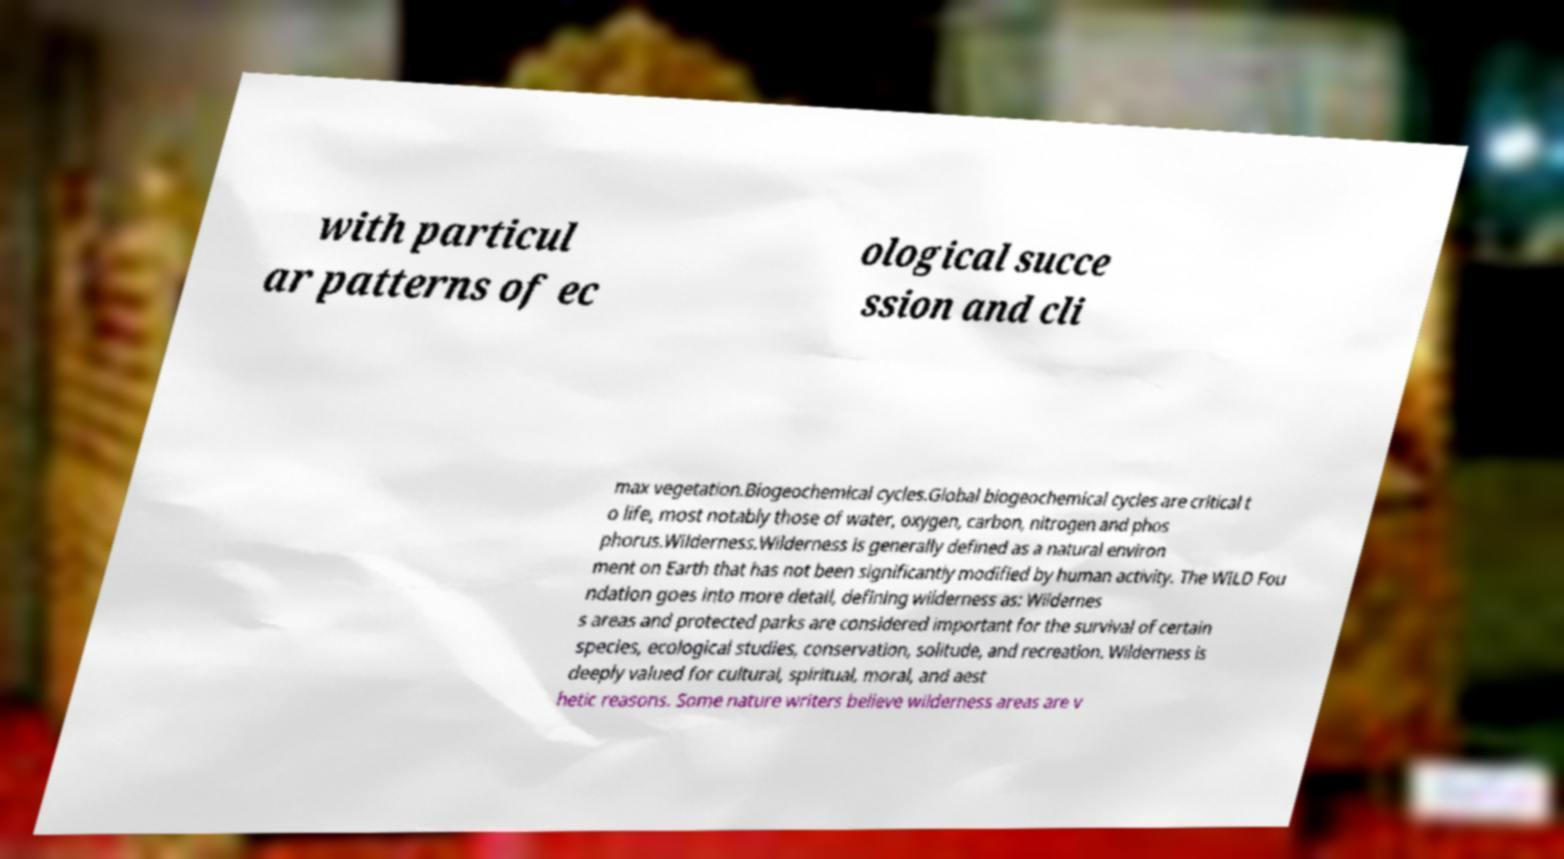Please identify and transcribe the text found in this image. with particul ar patterns of ec ological succe ssion and cli max vegetation.Biogeochemical cycles.Global biogeochemical cycles are critical t o life, most notably those of water, oxygen, carbon, nitrogen and phos phorus.Wilderness.Wilderness is generally defined as a natural environ ment on Earth that has not been significantly modified by human activity. The WILD Fou ndation goes into more detail, defining wilderness as: Wildernes s areas and protected parks are considered important for the survival of certain species, ecological studies, conservation, solitude, and recreation. Wilderness is deeply valued for cultural, spiritual, moral, and aest hetic reasons. Some nature writers believe wilderness areas are v 